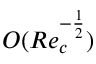<formula> <loc_0><loc_0><loc_500><loc_500>O ( R e _ { c } ^ { - \frac { 1 } { 2 } } )</formula> 